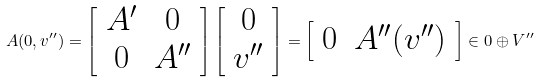<formula> <loc_0><loc_0><loc_500><loc_500>A ( 0 , v ^ { \prime \prime } ) = \left [ \begin{array} { c c } A ^ { \prime } & 0 \\ 0 & A ^ { \prime \prime } \end{array} \right ] \left [ \begin{array} { c } 0 \\ v ^ { \prime \prime } \end{array} \right ] = \left [ \begin{array} { c c } 0 & A ^ { \prime \prime } ( v ^ { \prime \prime } ) \end{array} \right ] \in 0 \oplus V ^ { \prime \prime }</formula> 